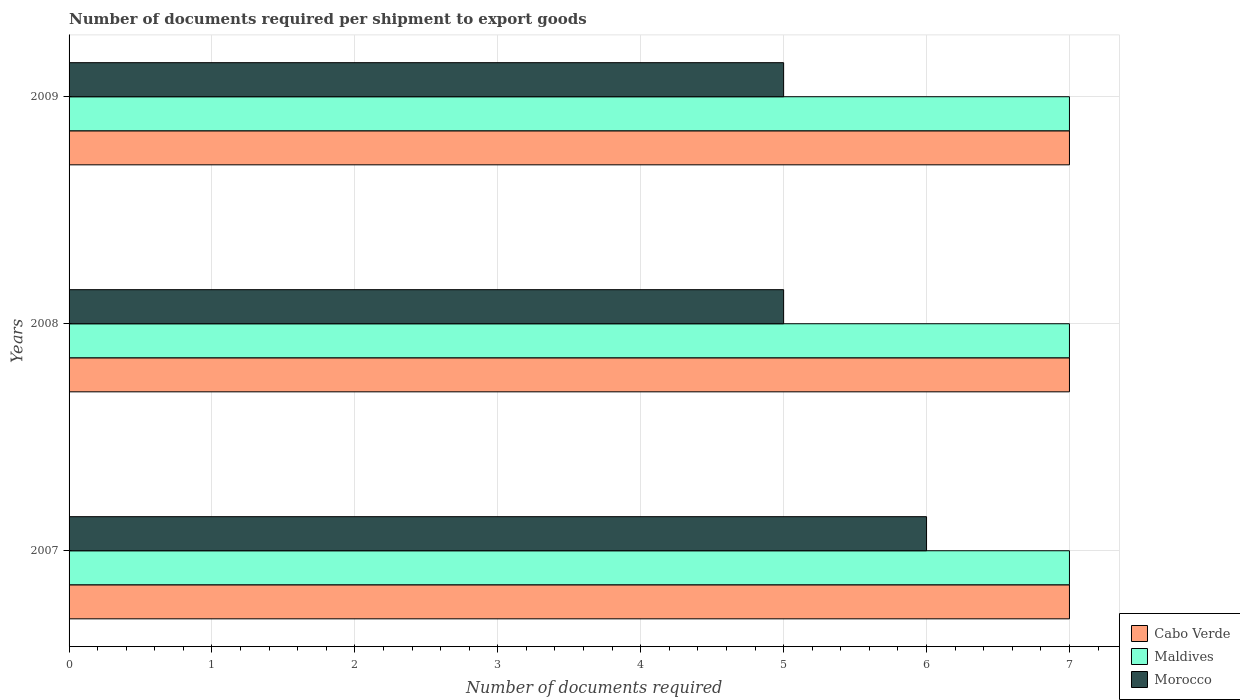How many groups of bars are there?
Provide a succinct answer. 3. Are the number of bars per tick equal to the number of legend labels?
Provide a short and direct response. Yes. How many bars are there on the 2nd tick from the top?
Provide a succinct answer. 3. How many bars are there on the 2nd tick from the bottom?
Offer a terse response. 3. In how many cases, is the number of bars for a given year not equal to the number of legend labels?
Your response must be concise. 0. What is the number of documents required per shipment to export goods in Morocco in 2009?
Provide a short and direct response. 5. Across all years, what is the maximum number of documents required per shipment to export goods in Cabo Verde?
Give a very brief answer. 7. Across all years, what is the minimum number of documents required per shipment to export goods in Morocco?
Your answer should be very brief. 5. In which year was the number of documents required per shipment to export goods in Morocco maximum?
Provide a short and direct response. 2007. What is the total number of documents required per shipment to export goods in Morocco in the graph?
Give a very brief answer. 16. What is the difference between the number of documents required per shipment to export goods in Morocco in 2008 and the number of documents required per shipment to export goods in Maldives in 2007?
Make the answer very short. -2. What is the average number of documents required per shipment to export goods in Morocco per year?
Keep it short and to the point. 5.33. In the year 2007, what is the difference between the number of documents required per shipment to export goods in Morocco and number of documents required per shipment to export goods in Cabo Verde?
Keep it short and to the point. -1. In how many years, is the number of documents required per shipment to export goods in Maldives greater than 3.4 ?
Your answer should be compact. 3. What is the ratio of the number of documents required per shipment to export goods in Cabo Verde in 2007 to that in 2008?
Provide a short and direct response. 1. Is the number of documents required per shipment to export goods in Morocco in 2007 less than that in 2008?
Keep it short and to the point. No. Is the difference between the number of documents required per shipment to export goods in Morocco in 2007 and 2008 greater than the difference between the number of documents required per shipment to export goods in Cabo Verde in 2007 and 2008?
Provide a short and direct response. Yes. What is the difference between the highest and the lowest number of documents required per shipment to export goods in Morocco?
Offer a very short reply. 1. What does the 2nd bar from the top in 2007 represents?
Your answer should be very brief. Maldives. What does the 2nd bar from the bottom in 2008 represents?
Your answer should be compact. Maldives. Is it the case that in every year, the sum of the number of documents required per shipment to export goods in Cabo Verde and number of documents required per shipment to export goods in Maldives is greater than the number of documents required per shipment to export goods in Morocco?
Your answer should be very brief. Yes. How many bars are there?
Provide a succinct answer. 9. Are all the bars in the graph horizontal?
Your answer should be compact. Yes. What is the difference between two consecutive major ticks on the X-axis?
Provide a succinct answer. 1. Are the values on the major ticks of X-axis written in scientific E-notation?
Ensure brevity in your answer.  No. Does the graph contain any zero values?
Give a very brief answer. No. Does the graph contain grids?
Your answer should be compact. Yes. What is the title of the graph?
Make the answer very short. Number of documents required per shipment to export goods. Does "Low income" appear as one of the legend labels in the graph?
Your answer should be very brief. No. What is the label or title of the X-axis?
Ensure brevity in your answer.  Number of documents required. What is the Number of documents required in Cabo Verde in 2008?
Offer a terse response. 7. What is the Number of documents required of Morocco in 2008?
Keep it short and to the point. 5. What is the Number of documents required in Maldives in 2009?
Ensure brevity in your answer.  7. Across all years, what is the maximum Number of documents required in Cabo Verde?
Ensure brevity in your answer.  7. Across all years, what is the maximum Number of documents required in Morocco?
Your answer should be very brief. 6. Across all years, what is the minimum Number of documents required of Morocco?
Provide a succinct answer. 5. What is the total Number of documents required in Cabo Verde in the graph?
Offer a very short reply. 21. What is the total Number of documents required in Maldives in the graph?
Your answer should be very brief. 21. What is the total Number of documents required of Morocco in the graph?
Your answer should be very brief. 16. What is the difference between the Number of documents required of Cabo Verde in 2007 and that in 2008?
Your answer should be compact. 0. What is the difference between the Number of documents required of Morocco in 2007 and that in 2008?
Your answer should be very brief. 1. What is the difference between the Number of documents required in Cabo Verde in 2007 and that in 2009?
Provide a succinct answer. 0. What is the difference between the Number of documents required in Cabo Verde in 2008 and that in 2009?
Keep it short and to the point. 0. What is the difference between the Number of documents required of Maldives in 2008 and that in 2009?
Your answer should be very brief. 0. What is the difference between the Number of documents required of Maldives in 2007 and the Number of documents required of Morocco in 2008?
Ensure brevity in your answer.  2. What is the difference between the Number of documents required of Cabo Verde in 2007 and the Number of documents required of Maldives in 2009?
Give a very brief answer. 0. What is the difference between the Number of documents required in Maldives in 2007 and the Number of documents required in Morocco in 2009?
Make the answer very short. 2. What is the difference between the Number of documents required in Cabo Verde in 2008 and the Number of documents required in Maldives in 2009?
Your answer should be very brief. 0. What is the average Number of documents required of Cabo Verde per year?
Provide a succinct answer. 7. What is the average Number of documents required in Morocco per year?
Your answer should be compact. 5.33. In the year 2007, what is the difference between the Number of documents required of Cabo Verde and Number of documents required of Morocco?
Offer a very short reply. 1. In the year 2007, what is the difference between the Number of documents required of Maldives and Number of documents required of Morocco?
Your answer should be very brief. 1. In the year 2008, what is the difference between the Number of documents required in Cabo Verde and Number of documents required in Morocco?
Provide a short and direct response. 2. In the year 2009, what is the difference between the Number of documents required of Cabo Verde and Number of documents required of Morocco?
Provide a short and direct response. 2. In the year 2009, what is the difference between the Number of documents required in Maldives and Number of documents required in Morocco?
Your answer should be compact. 2. What is the ratio of the Number of documents required of Maldives in 2007 to that in 2008?
Make the answer very short. 1. What is the ratio of the Number of documents required of Maldives in 2007 to that in 2009?
Provide a succinct answer. 1. What is the ratio of the Number of documents required in Morocco in 2007 to that in 2009?
Your answer should be very brief. 1.2. What is the ratio of the Number of documents required in Cabo Verde in 2008 to that in 2009?
Offer a terse response. 1. What is the ratio of the Number of documents required in Morocco in 2008 to that in 2009?
Provide a succinct answer. 1. What is the difference between the highest and the second highest Number of documents required of Cabo Verde?
Your response must be concise. 0. What is the difference between the highest and the second highest Number of documents required of Maldives?
Offer a terse response. 0. What is the difference between the highest and the second highest Number of documents required of Morocco?
Give a very brief answer. 1. What is the difference between the highest and the lowest Number of documents required in Cabo Verde?
Give a very brief answer. 0. What is the difference between the highest and the lowest Number of documents required of Maldives?
Your answer should be compact. 0. 